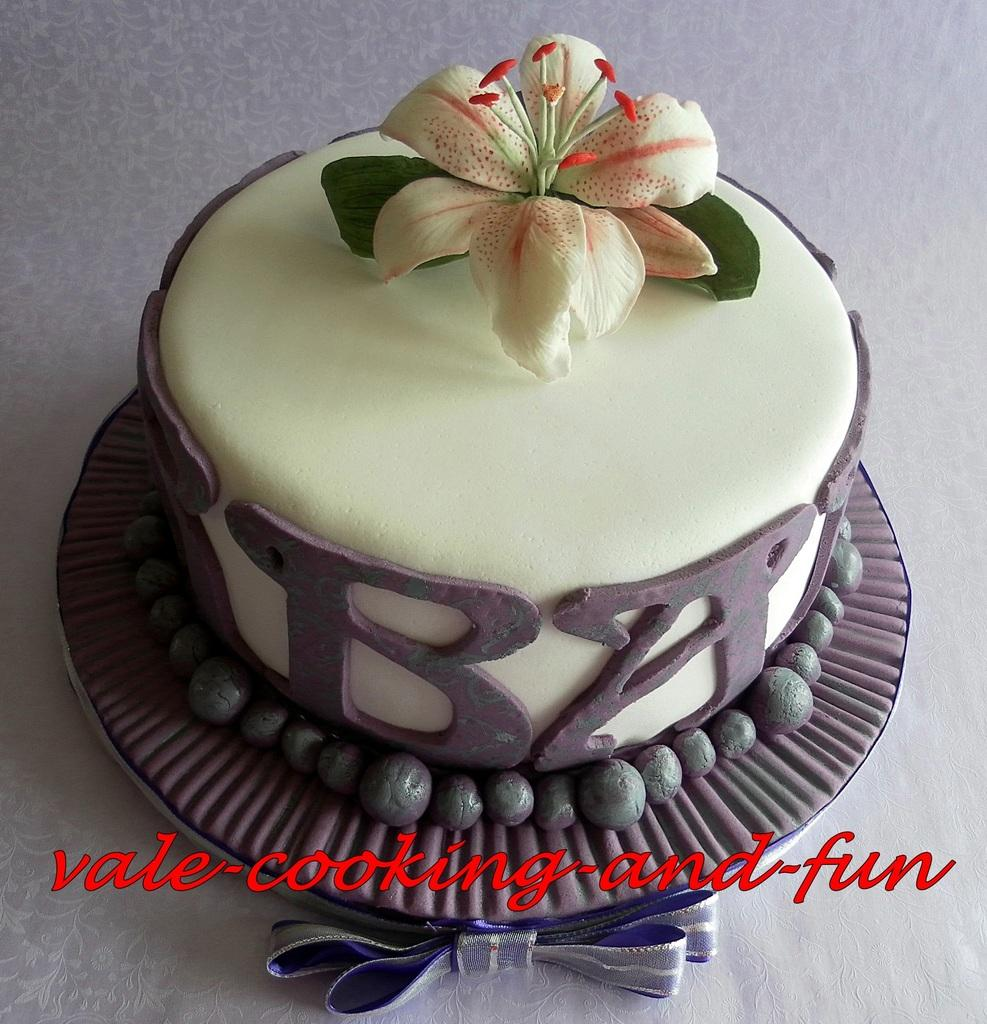What is the main subject in the center of the image? There is a chocolate cake in the center of the image. Can you describe the appearance of the chocolate cake? The chocolate cake appears to be a dessert with a rich, brown color. Are there any other objects or elements in the image besides the chocolate cake? The provided facts do not mention any other objects or elements in the image. What type of creature is taking a bite out of the chocolate cake in the image? There is no creature present in the image, and the chocolate cake does not show any signs of being bitten into. 